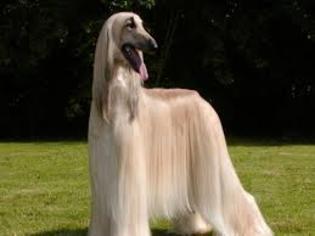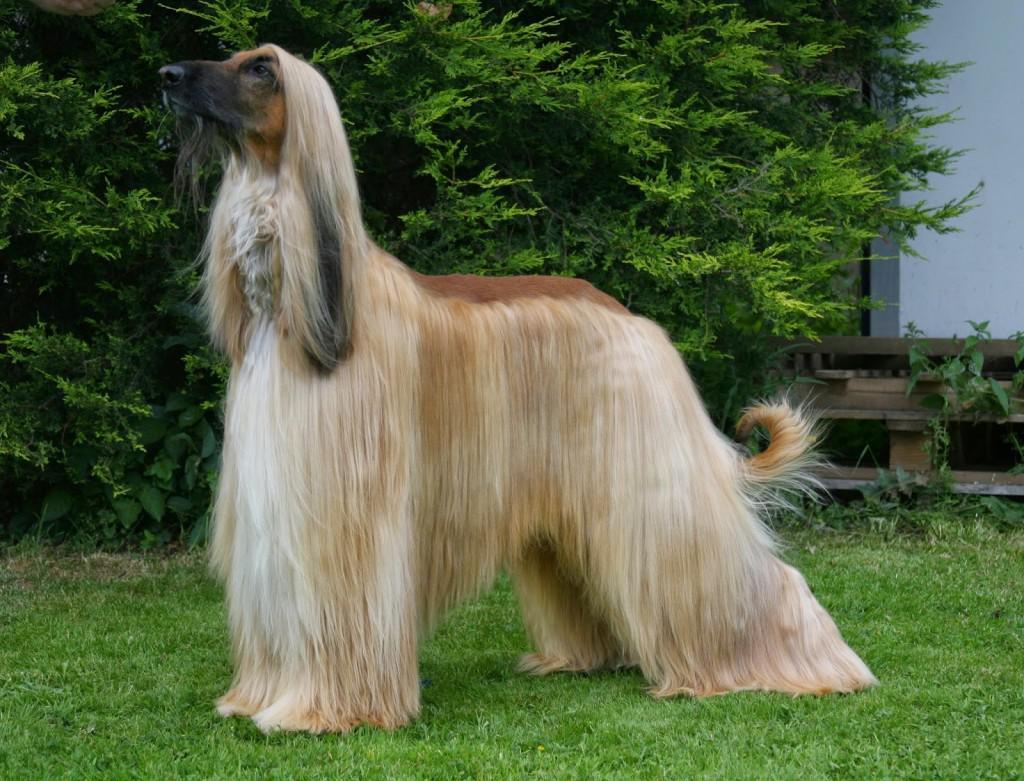The first image is the image on the left, the second image is the image on the right. Examine the images to the left and right. Is the description "Only the dog in the left image is standing on all fours." accurate? Answer yes or no. No. 